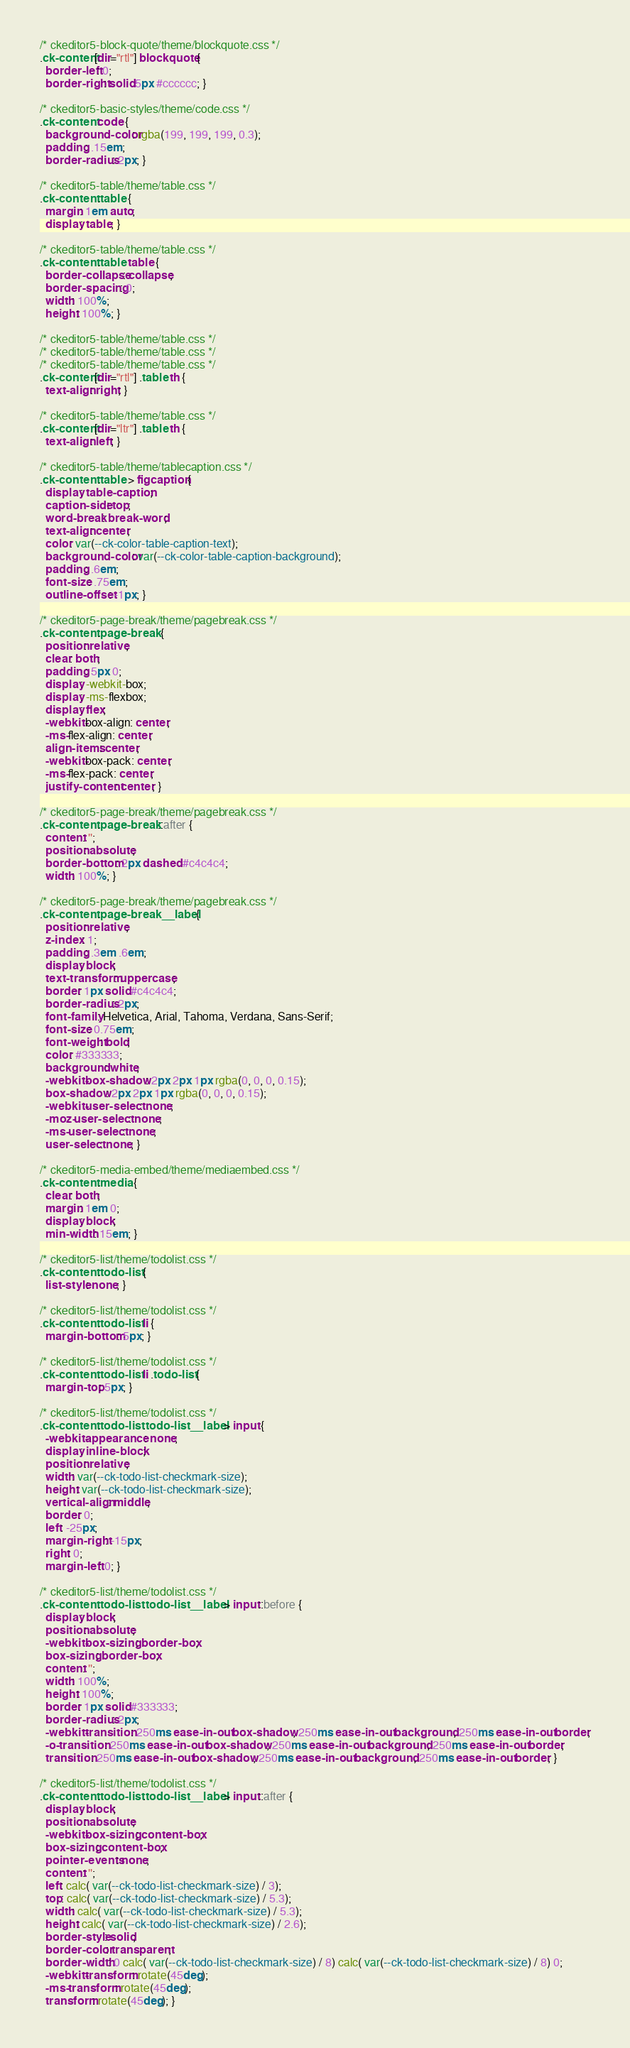<code> <loc_0><loc_0><loc_500><loc_500><_CSS_>
/* ckeditor5-block-quote/theme/blockquote.css */
.ck-content[dir="rtl"] blockquote {
  border-left: 0;
  border-right: solid 5px #cccccc; }

/* ckeditor5-basic-styles/theme/code.css */
.ck-content code {
  background-color: rgba(199, 199, 199, 0.3);
  padding: .15em;
  border-radius: 2px; }

/* ckeditor5-table/theme/table.css */
.ck-content .table {
  margin: 1em auto;
  display: table; }

/* ckeditor5-table/theme/table.css */
.ck-content .table table {
  border-collapse: collapse;
  border-spacing: 0;
  width: 100%;
  height: 100%; }

/* ckeditor5-table/theme/table.css */
/* ckeditor5-table/theme/table.css */
/* ckeditor5-table/theme/table.css */
.ck-content[dir="rtl"] .table th {
  text-align: right; }

/* ckeditor5-table/theme/table.css */
.ck-content[dir="ltr"] .table th {
  text-align: left; }

/* ckeditor5-table/theme/tablecaption.css */
.ck-content .table > figcaption {
  display: table-caption;
  caption-side: top;
  word-break: break-word;
  text-align: center;
  color: var(--ck-color-table-caption-text);
  background-color: var(--ck-color-table-caption-background);
  padding: .6em;
  font-size: .75em;
  outline-offset: -1px; }

/* ckeditor5-page-break/theme/pagebreak.css */
.ck-content .page-break {
  position: relative;
  clear: both;
  padding: 5px 0;
  display: -webkit-box;
  display: -ms-flexbox;
  display: flex;
  -webkit-box-align: center;
  -ms-flex-align: center;
  align-items: center;
  -webkit-box-pack: center;
  -ms-flex-pack: center;
  justify-content: center; }

/* ckeditor5-page-break/theme/pagebreak.css */
.ck-content .page-break::after {
  content: '';
  position: absolute;
  border-bottom: 2px dashed #c4c4c4;
  width: 100%; }

/* ckeditor5-page-break/theme/pagebreak.css */
.ck-content .page-break__label {
  position: relative;
  z-index: 1;
  padding: .3em .6em;
  display: block;
  text-transform: uppercase;
  border: 1px solid #c4c4c4;
  border-radius: 2px;
  font-family: Helvetica, Arial, Tahoma, Verdana, Sans-Serif;
  font-size: 0.75em;
  font-weight: bold;
  color: #333333;
  background: white;
  -webkit-box-shadow: 2px 2px 1px rgba(0, 0, 0, 0.15);
  box-shadow: 2px 2px 1px rgba(0, 0, 0, 0.15);
  -webkit-user-select: none;
  -moz-user-select: none;
  -ms-user-select: none;
  user-select: none; }

/* ckeditor5-media-embed/theme/mediaembed.css */
.ck-content .media {
  clear: both;
  margin: 1em 0;
  display: block;
  min-width: 15em; }

/* ckeditor5-list/theme/todolist.css */
.ck-content .todo-list {
  list-style: none; }

/* ckeditor5-list/theme/todolist.css */
.ck-content .todo-list li {
  margin-bottom: 5px; }

/* ckeditor5-list/theme/todolist.css */
.ck-content .todo-list li .todo-list {
  margin-top: 5px; }

/* ckeditor5-list/theme/todolist.css */
.ck-content .todo-list .todo-list__label > input {
  -webkit-appearance: none;
  display: inline-block;
  position: relative;
  width: var(--ck-todo-list-checkmark-size);
  height: var(--ck-todo-list-checkmark-size);
  vertical-align: middle;
  border: 0;
  left: -25px;
  margin-right: -15px;
  right: 0;
  margin-left: 0; }

/* ckeditor5-list/theme/todolist.css */
.ck-content .todo-list .todo-list__label > input::before {
  display: block;
  position: absolute;
  -webkit-box-sizing: border-box;
  box-sizing: border-box;
  content: '';
  width: 100%;
  height: 100%;
  border: 1px solid #333333;
  border-radius: 2px;
  -webkit-transition: 250ms ease-in-out box-shadow, 250ms ease-in-out background, 250ms ease-in-out border;
  -o-transition: 250ms ease-in-out box-shadow, 250ms ease-in-out background, 250ms ease-in-out border;
  transition: 250ms ease-in-out box-shadow, 250ms ease-in-out background, 250ms ease-in-out border; }

/* ckeditor5-list/theme/todolist.css */
.ck-content .todo-list .todo-list__label > input::after {
  display: block;
  position: absolute;
  -webkit-box-sizing: content-box;
  box-sizing: content-box;
  pointer-events: none;
  content: '';
  left: calc( var(--ck-todo-list-checkmark-size) / 3);
  top: calc( var(--ck-todo-list-checkmark-size) / 5.3);
  width: calc( var(--ck-todo-list-checkmark-size) / 5.3);
  height: calc( var(--ck-todo-list-checkmark-size) / 2.6);
  border-style: solid;
  border-color: transparent;
  border-width: 0 calc( var(--ck-todo-list-checkmark-size) / 8) calc( var(--ck-todo-list-checkmark-size) / 8) 0;
  -webkit-transform: rotate(45deg);
  -ms-transform: rotate(45deg);
  transform: rotate(45deg); }
</code> 